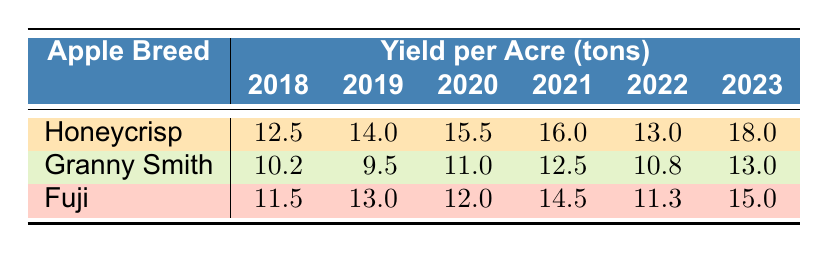What was the yield per acre of Honeycrisp apples in 2021? The table shows that the yield per acre for Honeycrisp apples in 2021 is listed directly under the 2021 column for Honeycrisp, which is 16.0 tons.
Answer: 16.0 What is the total yield of Granny Smith apples from 2018 to 2020? The yields for Granny Smith apples from 2018 to 2020 are: 2040 in 2018, 1900 in 2019, and 2200 in 2020. Adding these yields: 2040 + 1900 + 2200 = 6140.
Answer: 6140 Did the yield per acre of Fuji apples increase from 2020 to 2021? In 2020, the yield per acre for Fuji apples was 12.0 tons, and in 2021 it increased to 14.5 tons. Since 14.5 is greater than 12.0, the yield did increase.
Answer: Yes What is the average yield per acre of Honeycrisp apples over the years in the table? The yields for Honeycrisp apples are: 12.5 (2018), 14.0 (2019), 15.5 (2020), 16.0 (2021), 13.0 (2022), and 18.0 (2023). Summing these: 12.5 + 14.0 + 15.5 + 16.0 + 13.0 + 18.0 = 89.0. There are 6 years, so the average is 89.0 / 6 = 14.83 (rounded to two decimal places).
Answer: 14.83 Which apple breed had the highest yield per acre in 2023? From the table, the yields for 2023 are 18.0 for Honeycrisp, 13.0 for Granny Smith, and 15.0 for Fuji. Comparing these values, Honeycrisp has the highest yield per acre in 2023.
Answer: Honeycrisp Based on the table, which year had the lowest total yield for Granny Smith apples? The total yields for Granny Smith are: 2040 (2018), 1900 (2019), 2200 (2020), 2500 (2021), 2160 (2022), and 2600 (2023). The lowest yield is 1900 in 2019.
Answer: 2019 What is the difference in yield per acre for Fuji apples between 2018 and 2023? In 2018, Fuji apples had a yield per acre of 11.5 tons, and in 2023 it was 15.0 tons. The difference is 15.0 - 11.5 = 3.5 tons.
Answer: 3.5 For which breed was the yield in 2022 higher than the 2021 yield? Looking at the yields, Granny Smith in 2022 had a yield of 10.8 tons compared to 12.5 tons in 2021 (lower), whilst Fuji decreased from 14.5 to 11.3 tons (also lower). Honeycrisp had 13.0 tons in 2022, which is lower than 16.0 in 2021, hence none had a higher yield in 2022.
Answer: None 